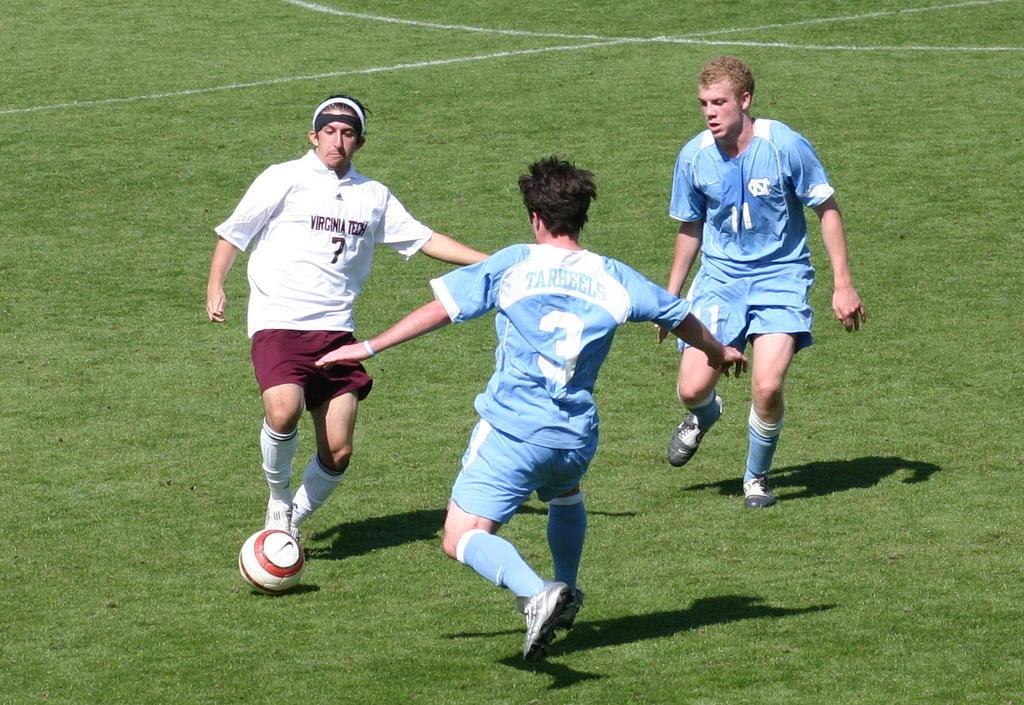How many people are playing football in the image? There are three men in the image playing football. Where is the football game taking place? The football game is taking place on a ground. What type of hose is being used by the police to control the insects during the football game? There is no hose, insects, or police present in the image; it only shows three men playing football on a ground. 